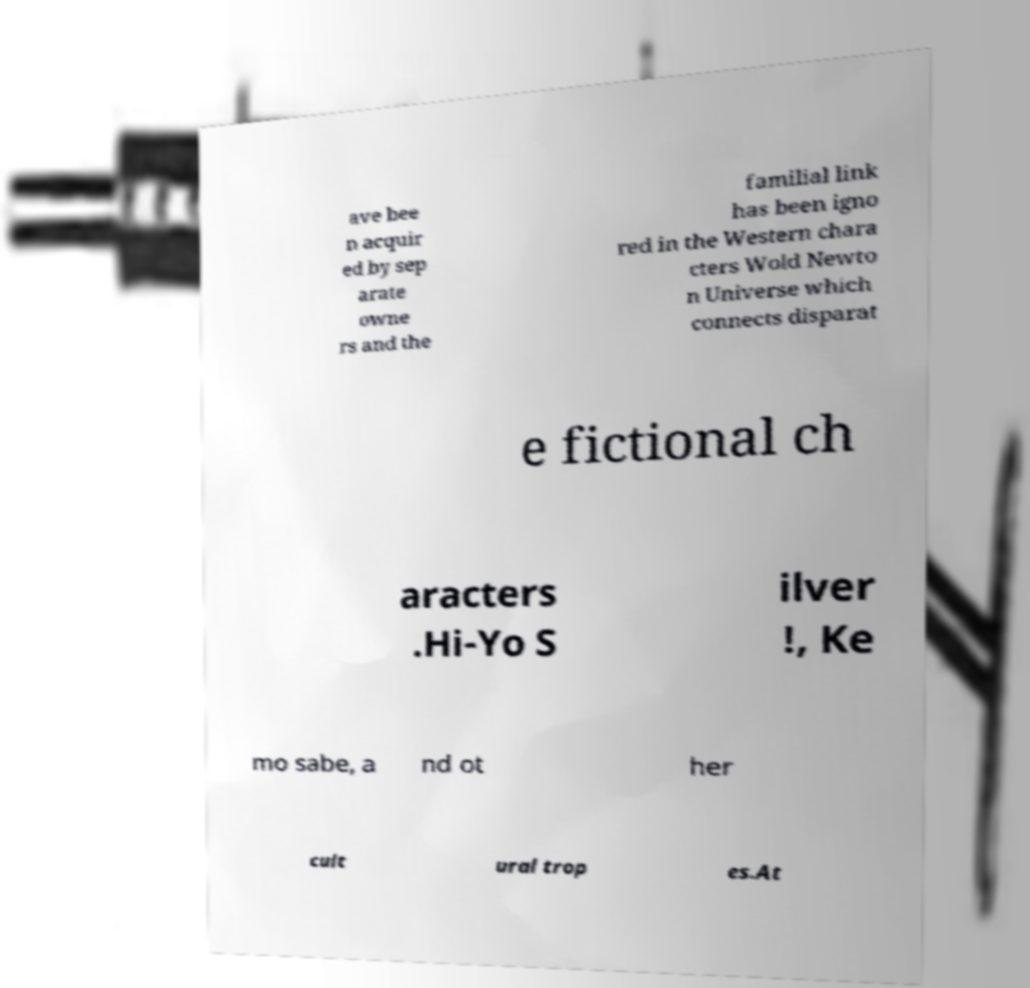I need the written content from this picture converted into text. Can you do that? ave bee n acquir ed by sep arate owne rs and the familial link has been igno red in the Western chara cters Wold Newto n Universe which connects disparat e fictional ch aracters .Hi-Yo S ilver !, Ke mo sabe, a nd ot her cult ural trop es.At 